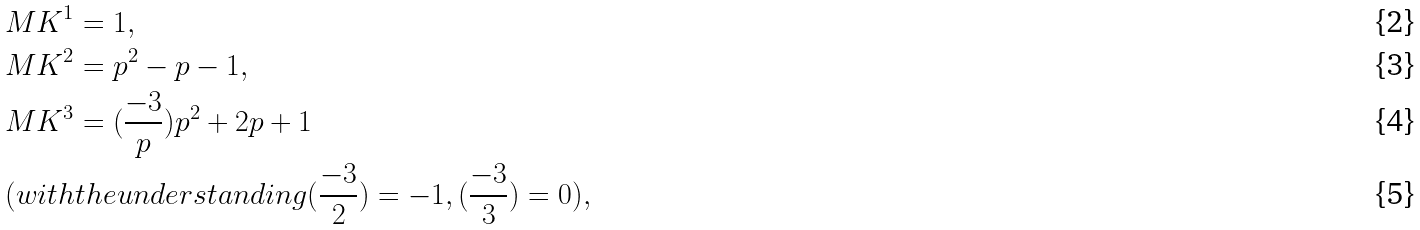Convert formula to latex. <formula><loc_0><loc_0><loc_500><loc_500>& M K ^ { 1 } = 1 , \\ & M K ^ { 2 } = p ^ { 2 } - p - 1 , \\ & M K ^ { 3 } = ( \frac { - 3 } { p } ) p ^ { 2 } + 2 p + 1 \\ & ( w i t h t h e u n d e r s t a n d i n g ( \frac { - 3 } { 2 } ) = - 1 , ( \frac { - 3 } { 3 } ) = 0 ) ,</formula> 